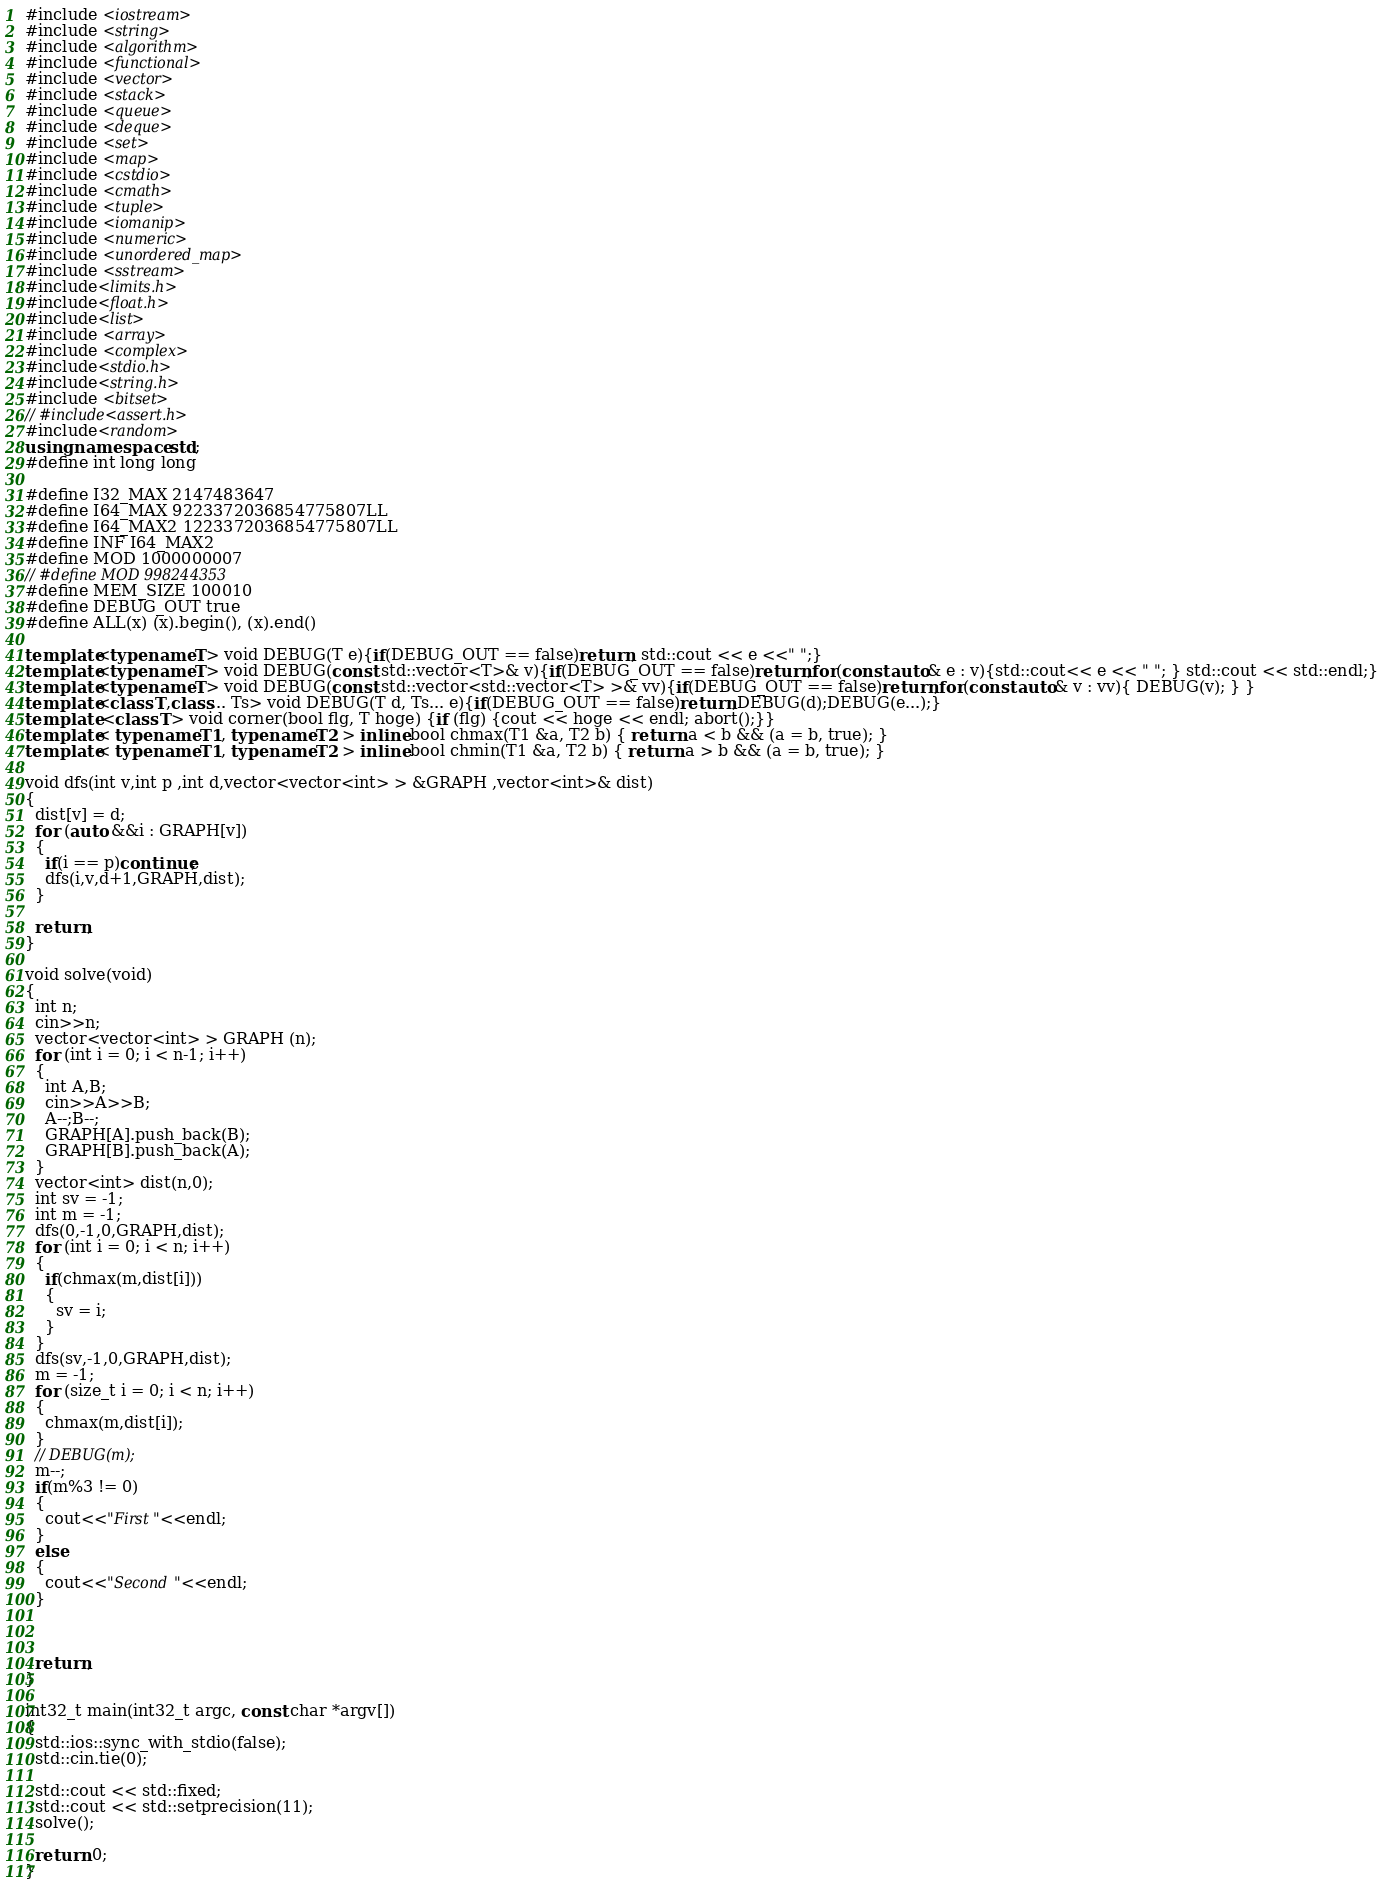<code> <loc_0><loc_0><loc_500><loc_500><_C++_>
#include <iostream>
#include <string>
#include <algorithm>
#include <functional>
#include <vector>
#include <stack>
#include <queue>
#include <deque>
#include <set>
#include <map>
#include <cstdio>
#include <cmath>
#include <tuple>
#include <iomanip>
#include <numeric>
#include <unordered_map>
#include <sstream>
#include<limits.h>
#include<float.h>
#include<list>
#include <array>
#include <complex>
#include<stdio.h>
#include<string.h>
#include <bitset>
// #include<assert.h>
#include<random>
using namespace std;
#define int long long

#define I32_MAX 2147483647
#define I64_MAX 9223372036854775807LL
#define I64_MAX2 1223372036854775807LL
#define INF I64_MAX2
#define MOD 1000000007
// #define MOD 998244353 
#define MEM_SIZE 100010
#define DEBUG_OUT true
#define ALL(x) (x).begin(), (x).end()

template<typename T> void DEBUG(T e){if(DEBUG_OUT == false)return; std::cout << e <<" ";}
template<typename T> void DEBUG(const std::vector<T>& v){if(DEBUG_OUT == false)return;for(const auto& e : v){std::cout<< e << " "; } std::cout << std::endl;}
template<typename T> void DEBUG(const std::vector<std::vector<T> >& vv){if(DEBUG_OUT == false)return;for(const auto& v : vv){ DEBUG(v); } }
template<class T,class... Ts> void DEBUG(T d, Ts... e){if(DEBUG_OUT == false)return;DEBUG(d);DEBUG(e...);}
template <class T> void corner(bool flg, T hoge) {if (flg) {cout << hoge << endl; abort();}}
template< typename T1, typename T2 > inline bool chmax(T1 &a, T2 b) { return a < b && (a = b, true); }
template< typename T1, typename T2 > inline bool chmin(T1 &a, T2 b) { return a > b && (a = b, true); }

void dfs(int v,int p ,int d,vector<vector<int> > &GRAPH ,vector<int>& dist)
{
  dist[v] = d;
  for (auto &&i : GRAPH[v])
  {
    if(i == p)continue;
    dfs(i,v,d+1,GRAPH,dist);
  }
  
  return;
}

void solve(void)
{
  int n;
  cin>>n;
  vector<vector<int> > GRAPH (n);
  for (int i = 0; i < n-1; i++)
  {
    int A,B;
    cin>>A>>B;
    A--;B--;
    GRAPH[A].push_back(B);
    GRAPH[B].push_back(A);
  }
  vector<int> dist(n,0);
  int sv = -1;
  int m = -1;
  dfs(0,-1,0,GRAPH,dist);
  for (int i = 0; i < n; i++)
  {
    if(chmax(m,dist[i]))
    {
      sv = i;
    }
  }
  dfs(sv,-1,0,GRAPH,dist);
  m = -1;
  for (size_t i = 0; i < n; i++)
  {
    chmax(m,dist[i]);
  }
  // DEBUG(m);
  m--;
  if(m%3 != 0)
  {
    cout<<"First"<<endl;
  }
  else
  {
    cout<<"Second"<<endl;
  }
  
  
  
  return;
}

int32_t main(int32_t argc, const char *argv[])
{
  std::ios::sync_with_stdio(false);
  std::cin.tie(0);

  std::cout << std::fixed;
  std::cout << std::setprecision(11);
  solve();

  return 0;
}
</code> 